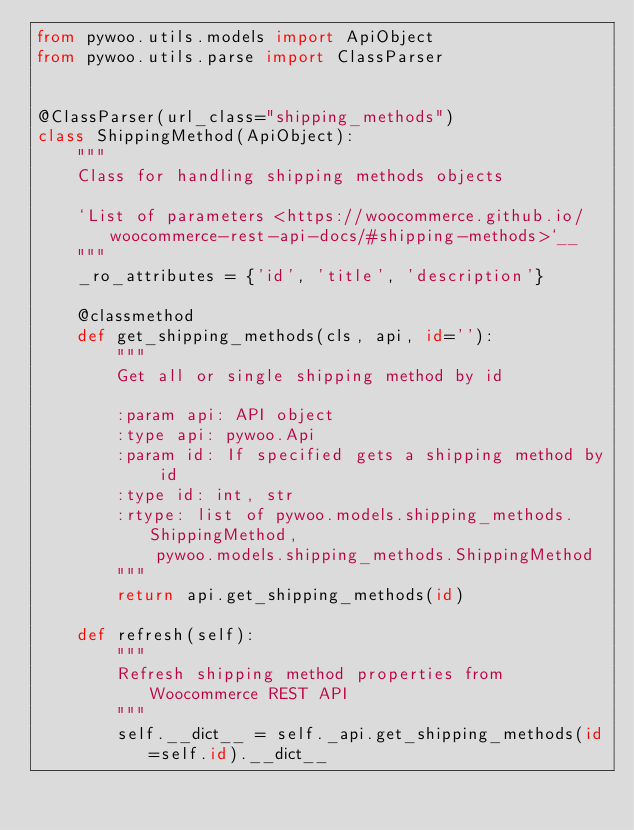<code> <loc_0><loc_0><loc_500><loc_500><_Python_>from pywoo.utils.models import ApiObject
from pywoo.utils.parse import ClassParser


@ClassParser(url_class="shipping_methods")
class ShippingMethod(ApiObject):
    """
    Class for handling shipping methods objects

    `List of parameters <https://woocommerce.github.io/woocommerce-rest-api-docs/#shipping-methods>`__
    """
    _ro_attributes = {'id', 'title', 'description'}

    @classmethod
    def get_shipping_methods(cls, api, id=''):
        """
        Get all or single shipping method by id

        :param api: API object
        :type api: pywoo.Api
        :param id: If specified gets a shipping method by id
        :type id: int, str
        :rtype: list of pywoo.models.shipping_methods.ShippingMethod,
            pywoo.models.shipping_methods.ShippingMethod
        """
        return api.get_shipping_methods(id)

    def refresh(self):
        """
        Refresh shipping method properties from Woocommerce REST API
        """
        self.__dict__ = self._api.get_shipping_methods(id=self.id).__dict__
</code> 